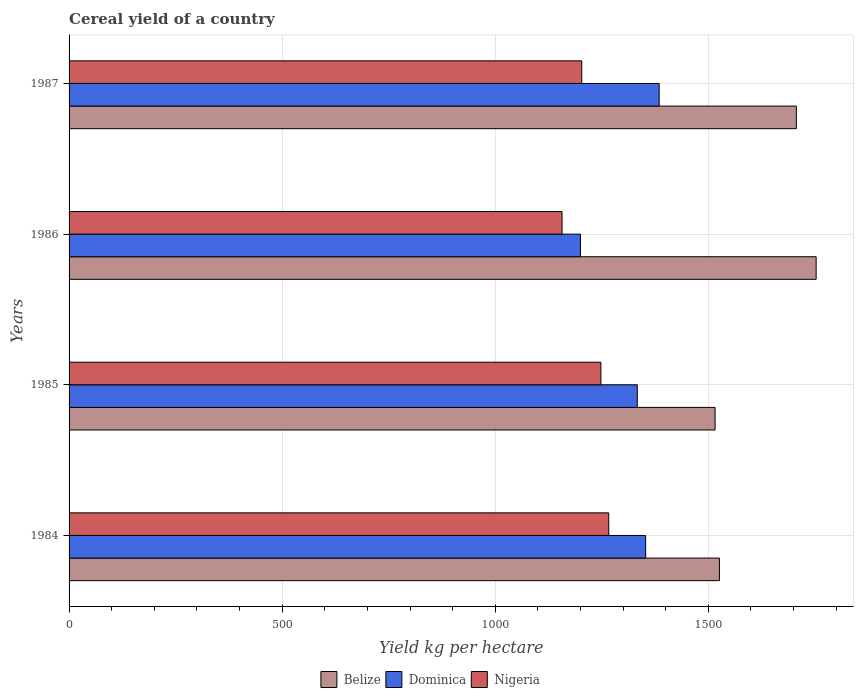How many bars are there on the 2nd tick from the top?
Offer a very short reply. 3. How many bars are there on the 2nd tick from the bottom?
Make the answer very short. 3. What is the label of the 1st group of bars from the top?
Offer a very short reply. 1987. What is the total cereal yield in Belize in 1984?
Give a very brief answer. 1526.04. Across all years, what is the maximum total cereal yield in Nigeria?
Your answer should be compact. 1266.34. Across all years, what is the minimum total cereal yield in Dominica?
Give a very brief answer. 1200. What is the total total cereal yield in Nigeria in the graph?
Keep it short and to the point. 4873.98. What is the difference between the total cereal yield in Dominica in 1984 and that in 1987?
Give a very brief answer. -31.67. What is the difference between the total cereal yield in Belize in 1986 and the total cereal yield in Dominica in 1984?
Make the answer very short. 400.05. What is the average total cereal yield in Belize per year?
Keep it short and to the point. 1625.38. In the year 1987, what is the difference between the total cereal yield in Dominica and total cereal yield in Belize?
Your response must be concise. -322.01. What is the ratio of the total cereal yield in Nigeria in 1984 to that in 1985?
Offer a very short reply. 1.01. Is the difference between the total cereal yield in Dominica in 1985 and 1986 greater than the difference between the total cereal yield in Belize in 1985 and 1986?
Offer a very short reply. Yes. What is the difference between the highest and the second highest total cereal yield in Dominica?
Offer a very short reply. 31.67. What is the difference between the highest and the lowest total cereal yield in Nigeria?
Keep it short and to the point. 109.62. Is the sum of the total cereal yield in Nigeria in 1984 and 1986 greater than the maximum total cereal yield in Belize across all years?
Your response must be concise. Yes. What does the 3rd bar from the top in 1987 represents?
Keep it short and to the point. Belize. What does the 1st bar from the bottom in 1984 represents?
Your answer should be compact. Belize. How many bars are there?
Provide a succinct answer. 12. Are all the bars in the graph horizontal?
Provide a succinct answer. Yes. What is the difference between two consecutive major ticks on the X-axis?
Give a very brief answer. 500. Are the values on the major ticks of X-axis written in scientific E-notation?
Provide a succinct answer. No. Does the graph contain any zero values?
Give a very brief answer. No. Where does the legend appear in the graph?
Your response must be concise. Bottom center. What is the title of the graph?
Ensure brevity in your answer.  Cereal yield of a country. What is the label or title of the X-axis?
Offer a terse response. Yield kg per hectare. What is the Yield kg per hectare of Belize in 1984?
Offer a very short reply. 1526.04. What is the Yield kg per hectare of Dominica in 1984?
Provide a short and direct response. 1352.94. What is the Yield kg per hectare in Nigeria in 1984?
Give a very brief answer. 1266.34. What is the Yield kg per hectare in Belize in 1985?
Offer a very short reply. 1515.88. What is the Yield kg per hectare of Dominica in 1985?
Offer a very short reply. 1333.33. What is the Yield kg per hectare in Nigeria in 1985?
Your answer should be compact. 1247.93. What is the Yield kg per hectare in Belize in 1986?
Offer a terse response. 1752.99. What is the Yield kg per hectare in Dominica in 1986?
Provide a succinct answer. 1200. What is the Yield kg per hectare of Nigeria in 1986?
Offer a terse response. 1156.71. What is the Yield kg per hectare of Belize in 1987?
Keep it short and to the point. 1706.63. What is the Yield kg per hectare in Dominica in 1987?
Your answer should be compact. 1384.62. What is the Yield kg per hectare in Nigeria in 1987?
Offer a terse response. 1203.01. Across all years, what is the maximum Yield kg per hectare of Belize?
Your response must be concise. 1752.99. Across all years, what is the maximum Yield kg per hectare in Dominica?
Make the answer very short. 1384.62. Across all years, what is the maximum Yield kg per hectare in Nigeria?
Keep it short and to the point. 1266.34. Across all years, what is the minimum Yield kg per hectare in Belize?
Keep it short and to the point. 1515.88. Across all years, what is the minimum Yield kg per hectare of Dominica?
Make the answer very short. 1200. Across all years, what is the minimum Yield kg per hectare in Nigeria?
Keep it short and to the point. 1156.71. What is the total Yield kg per hectare of Belize in the graph?
Provide a succinct answer. 6501.53. What is the total Yield kg per hectare in Dominica in the graph?
Give a very brief answer. 5270.89. What is the total Yield kg per hectare in Nigeria in the graph?
Your response must be concise. 4873.98. What is the difference between the Yield kg per hectare in Belize in 1984 and that in 1985?
Ensure brevity in your answer.  10.16. What is the difference between the Yield kg per hectare in Dominica in 1984 and that in 1985?
Offer a terse response. 19.61. What is the difference between the Yield kg per hectare in Nigeria in 1984 and that in 1985?
Your answer should be compact. 18.41. What is the difference between the Yield kg per hectare in Belize in 1984 and that in 1986?
Provide a succinct answer. -226.95. What is the difference between the Yield kg per hectare of Dominica in 1984 and that in 1986?
Make the answer very short. 152.94. What is the difference between the Yield kg per hectare of Nigeria in 1984 and that in 1986?
Offer a very short reply. 109.62. What is the difference between the Yield kg per hectare in Belize in 1984 and that in 1987?
Your answer should be compact. -180.59. What is the difference between the Yield kg per hectare in Dominica in 1984 and that in 1987?
Offer a very short reply. -31.67. What is the difference between the Yield kg per hectare in Nigeria in 1984 and that in 1987?
Your answer should be very brief. 63.33. What is the difference between the Yield kg per hectare of Belize in 1985 and that in 1986?
Offer a very short reply. -237.11. What is the difference between the Yield kg per hectare of Dominica in 1985 and that in 1986?
Your answer should be compact. 133.33. What is the difference between the Yield kg per hectare of Nigeria in 1985 and that in 1986?
Your response must be concise. 91.22. What is the difference between the Yield kg per hectare in Belize in 1985 and that in 1987?
Offer a terse response. -190.75. What is the difference between the Yield kg per hectare in Dominica in 1985 and that in 1987?
Your answer should be very brief. -51.28. What is the difference between the Yield kg per hectare of Nigeria in 1985 and that in 1987?
Make the answer very short. 44.92. What is the difference between the Yield kg per hectare in Belize in 1986 and that in 1987?
Your response must be concise. 46.36. What is the difference between the Yield kg per hectare in Dominica in 1986 and that in 1987?
Provide a succinct answer. -184.62. What is the difference between the Yield kg per hectare in Nigeria in 1986 and that in 1987?
Ensure brevity in your answer.  -46.3. What is the difference between the Yield kg per hectare of Belize in 1984 and the Yield kg per hectare of Dominica in 1985?
Offer a very short reply. 192.71. What is the difference between the Yield kg per hectare of Belize in 1984 and the Yield kg per hectare of Nigeria in 1985?
Your answer should be compact. 278.11. What is the difference between the Yield kg per hectare of Dominica in 1984 and the Yield kg per hectare of Nigeria in 1985?
Your answer should be very brief. 105.01. What is the difference between the Yield kg per hectare of Belize in 1984 and the Yield kg per hectare of Dominica in 1986?
Provide a short and direct response. 326.04. What is the difference between the Yield kg per hectare of Belize in 1984 and the Yield kg per hectare of Nigeria in 1986?
Keep it short and to the point. 369.33. What is the difference between the Yield kg per hectare of Dominica in 1984 and the Yield kg per hectare of Nigeria in 1986?
Ensure brevity in your answer.  196.23. What is the difference between the Yield kg per hectare of Belize in 1984 and the Yield kg per hectare of Dominica in 1987?
Give a very brief answer. 141.43. What is the difference between the Yield kg per hectare in Belize in 1984 and the Yield kg per hectare in Nigeria in 1987?
Ensure brevity in your answer.  323.03. What is the difference between the Yield kg per hectare in Dominica in 1984 and the Yield kg per hectare in Nigeria in 1987?
Your answer should be compact. 149.93. What is the difference between the Yield kg per hectare in Belize in 1985 and the Yield kg per hectare in Dominica in 1986?
Your answer should be compact. 315.88. What is the difference between the Yield kg per hectare in Belize in 1985 and the Yield kg per hectare in Nigeria in 1986?
Your response must be concise. 359.16. What is the difference between the Yield kg per hectare of Dominica in 1985 and the Yield kg per hectare of Nigeria in 1986?
Give a very brief answer. 176.62. What is the difference between the Yield kg per hectare of Belize in 1985 and the Yield kg per hectare of Dominica in 1987?
Offer a very short reply. 131.26. What is the difference between the Yield kg per hectare of Belize in 1985 and the Yield kg per hectare of Nigeria in 1987?
Your answer should be compact. 312.87. What is the difference between the Yield kg per hectare in Dominica in 1985 and the Yield kg per hectare in Nigeria in 1987?
Give a very brief answer. 130.32. What is the difference between the Yield kg per hectare in Belize in 1986 and the Yield kg per hectare in Dominica in 1987?
Provide a short and direct response. 368.37. What is the difference between the Yield kg per hectare of Belize in 1986 and the Yield kg per hectare of Nigeria in 1987?
Keep it short and to the point. 549.98. What is the difference between the Yield kg per hectare of Dominica in 1986 and the Yield kg per hectare of Nigeria in 1987?
Give a very brief answer. -3.01. What is the average Yield kg per hectare of Belize per year?
Offer a terse response. 1625.38. What is the average Yield kg per hectare in Dominica per year?
Your response must be concise. 1317.72. What is the average Yield kg per hectare in Nigeria per year?
Offer a terse response. 1218.5. In the year 1984, what is the difference between the Yield kg per hectare of Belize and Yield kg per hectare of Dominica?
Your answer should be very brief. 173.1. In the year 1984, what is the difference between the Yield kg per hectare in Belize and Yield kg per hectare in Nigeria?
Ensure brevity in your answer.  259.7. In the year 1984, what is the difference between the Yield kg per hectare of Dominica and Yield kg per hectare of Nigeria?
Provide a succinct answer. 86.6. In the year 1985, what is the difference between the Yield kg per hectare of Belize and Yield kg per hectare of Dominica?
Keep it short and to the point. 182.54. In the year 1985, what is the difference between the Yield kg per hectare in Belize and Yield kg per hectare in Nigeria?
Offer a very short reply. 267.95. In the year 1985, what is the difference between the Yield kg per hectare of Dominica and Yield kg per hectare of Nigeria?
Your answer should be compact. 85.41. In the year 1986, what is the difference between the Yield kg per hectare of Belize and Yield kg per hectare of Dominica?
Provide a succinct answer. 552.99. In the year 1986, what is the difference between the Yield kg per hectare of Belize and Yield kg per hectare of Nigeria?
Keep it short and to the point. 596.27. In the year 1986, what is the difference between the Yield kg per hectare of Dominica and Yield kg per hectare of Nigeria?
Offer a very short reply. 43.29. In the year 1987, what is the difference between the Yield kg per hectare in Belize and Yield kg per hectare in Dominica?
Offer a terse response. 322.01. In the year 1987, what is the difference between the Yield kg per hectare of Belize and Yield kg per hectare of Nigeria?
Make the answer very short. 503.62. In the year 1987, what is the difference between the Yield kg per hectare in Dominica and Yield kg per hectare in Nigeria?
Your answer should be compact. 181.61. What is the ratio of the Yield kg per hectare of Belize in 1984 to that in 1985?
Your answer should be compact. 1.01. What is the ratio of the Yield kg per hectare of Dominica in 1984 to that in 1985?
Ensure brevity in your answer.  1.01. What is the ratio of the Yield kg per hectare in Nigeria in 1984 to that in 1985?
Provide a short and direct response. 1.01. What is the ratio of the Yield kg per hectare of Belize in 1984 to that in 1986?
Make the answer very short. 0.87. What is the ratio of the Yield kg per hectare of Dominica in 1984 to that in 1986?
Keep it short and to the point. 1.13. What is the ratio of the Yield kg per hectare in Nigeria in 1984 to that in 1986?
Make the answer very short. 1.09. What is the ratio of the Yield kg per hectare in Belize in 1984 to that in 1987?
Keep it short and to the point. 0.89. What is the ratio of the Yield kg per hectare in Dominica in 1984 to that in 1987?
Your response must be concise. 0.98. What is the ratio of the Yield kg per hectare in Nigeria in 1984 to that in 1987?
Make the answer very short. 1.05. What is the ratio of the Yield kg per hectare of Belize in 1985 to that in 1986?
Offer a terse response. 0.86. What is the ratio of the Yield kg per hectare in Nigeria in 1985 to that in 1986?
Offer a terse response. 1.08. What is the ratio of the Yield kg per hectare of Belize in 1985 to that in 1987?
Your answer should be very brief. 0.89. What is the ratio of the Yield kg per hectare of Dominica in 1985 to that in 1987?
Make the answer very short. 0.96. What is the ratio of the Yield kg per hectare in Nigeria in 1985 to that in 1987?
Make the answer very short. 1.04. What is the ratio of the Yield kg per hectare in Belize in 1986 to that in 1987?
Your answer should be very brief. 1.03. What is the ratio of the Yield kg per hectare in Dominica in 1986 to that in 1987?
Give a very brief answer. 0.87. What is the ratio of the Yield kg per hectare of Nigeria in 1986 to that in 1987?
Keep it short and to the point. 0.96. What is the difference between the highest and the second highest Yield kg per hectare of Belize?
Provide a succinct answer. 46.36. What is the difference between the highest and the second highest Yield kg per hectare of Dominica?
Keep it short and to the point. 31.67. What is the difference between the highest and the second highest Yield kg per hectare of Nigeria?
Give a very brief answer. 18.41. What is the difference between the highest and the lowest Yield kg per hectare in Belize?
Offer a terse response. 237.11. What is the difference between the highest and the lowest Yield kg per hectare in Dominica?
Keep it short and to the point. 184.62. What is the difference between the highest and the lowest Yield kg per hectare of Nigeria?
Make the answer very short. 109.62. 